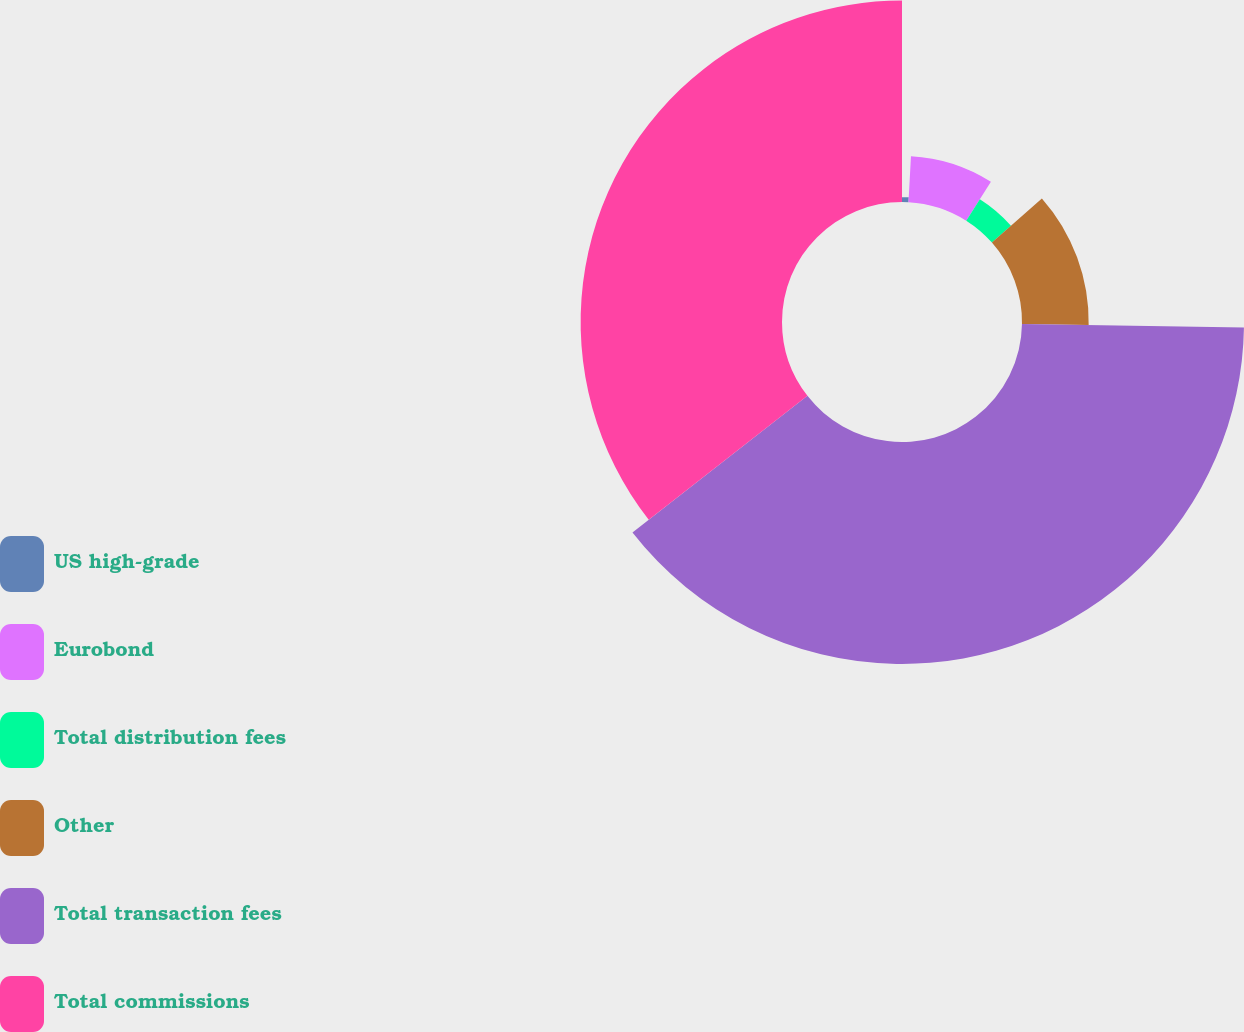Convert chart. <chart><loc_0><loc_0><loc_500><loc_500><pie_chart><fcel>US high-grade<fcel>Eurobond<fcel>Total distribution fees<fcel>Other<fcel>Total transaction fees<fcel>Total commissions<nl><fcel>0.86%<fcel>8.13%<fcel>4.49%<fcel>11.77%<fcel>39.19%<fcel>35.55%<nl></chart> 